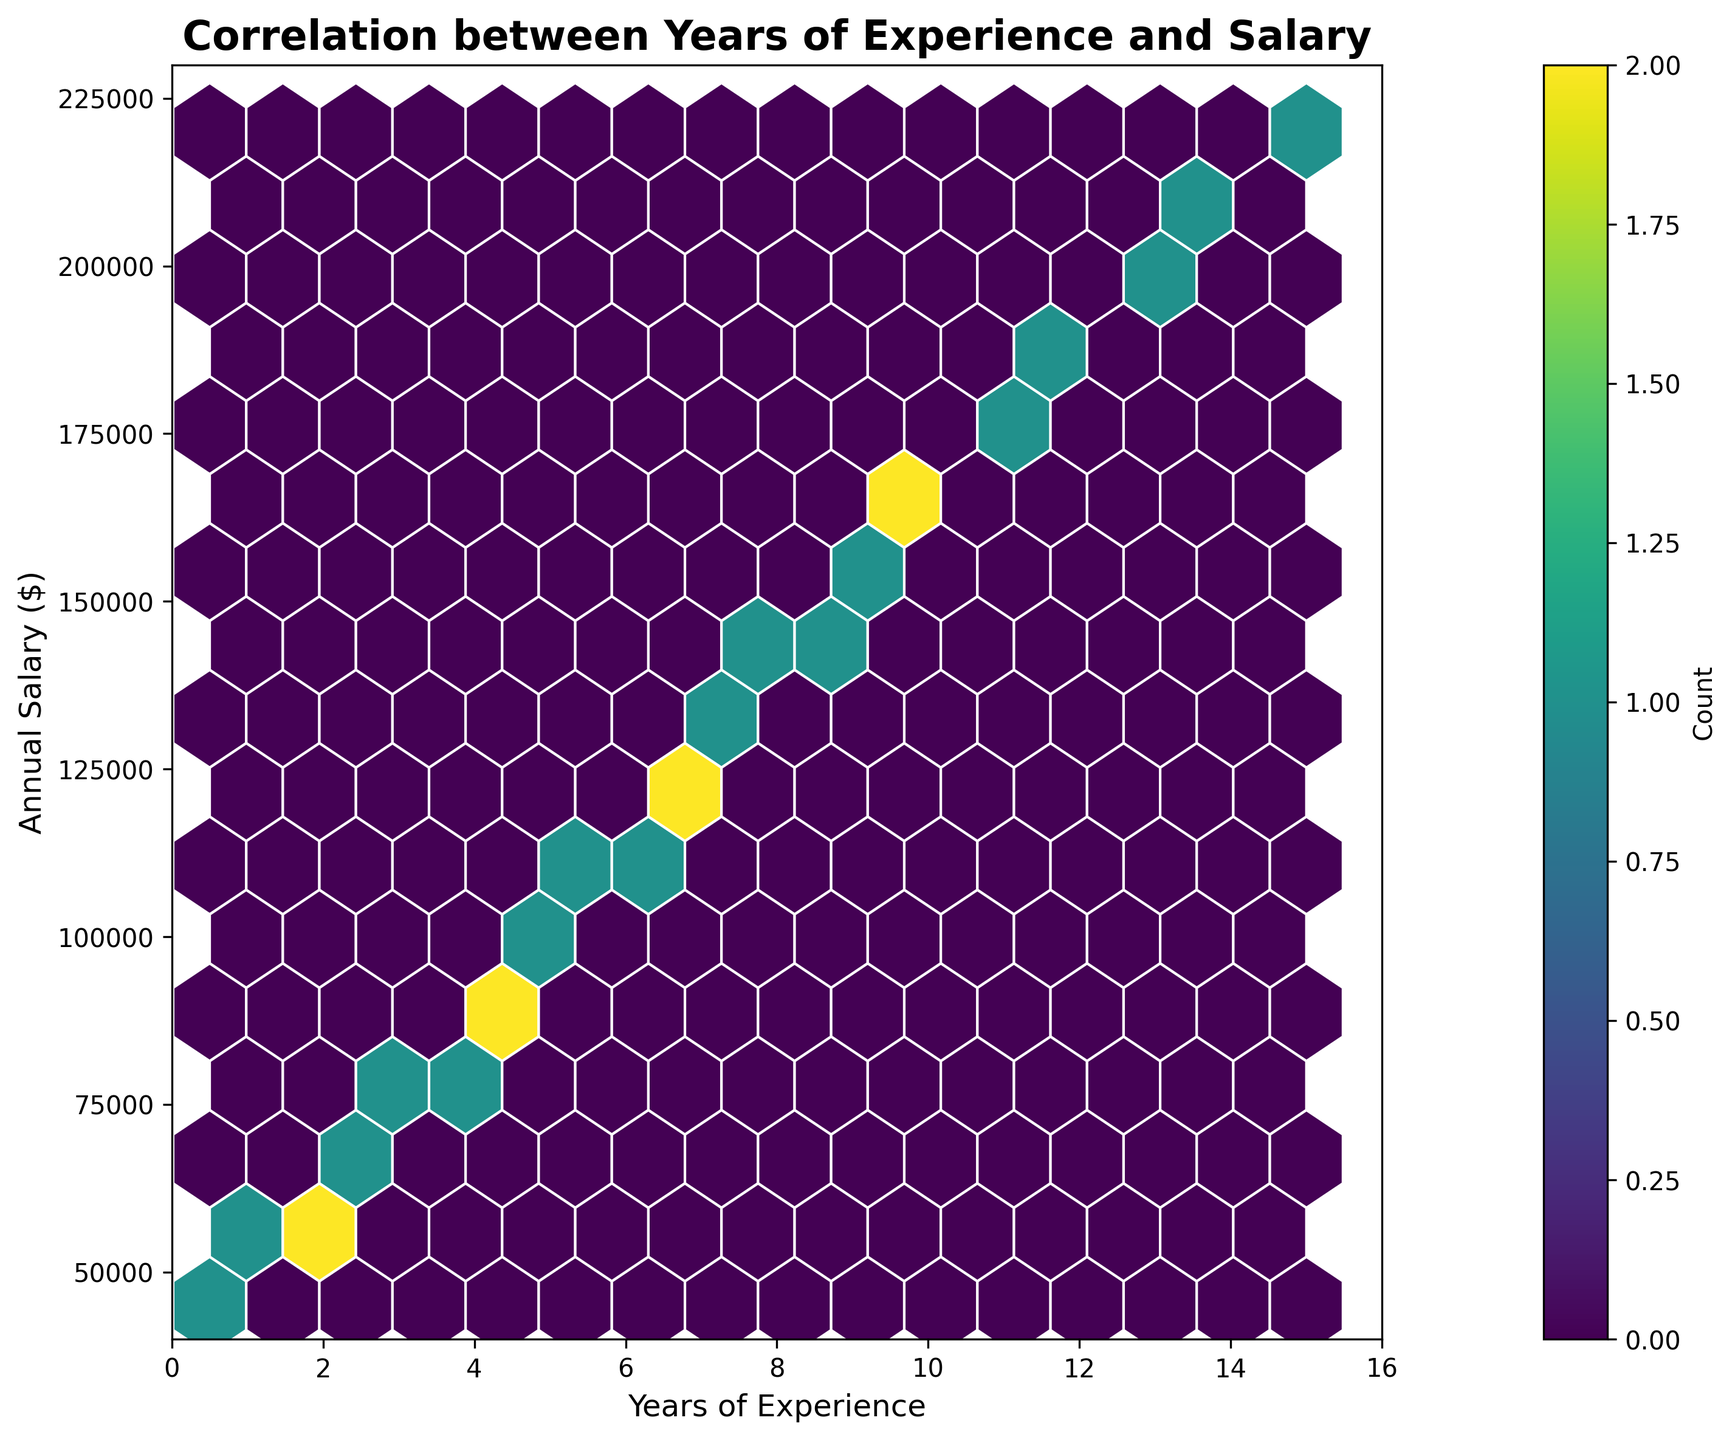What's the title of the chart? The title of the chart is located at the top and explains what the chart is about.
Answer: Correlation between Years of Experience and Salary What do the X and Y axes represent? The X-axis represents 'Years of Experience' and the Y-axis represents 'Annual Salary ($)', as labeled on the axes.
Answer: Years of Experience and Annual Salary ($) What are the minimum and maximum ranges for the X and Y axes? The minimum range for the X-axis is 0 and the maximum is 16; for the Y-axis, the minimum is 40,000 and the maximum is 230,000, as seen from the axis labels and ticks.
Answer: X-axis: 0 to 16, Y-axis: 40,000 to 230,000 Where is the highest density of data points located? The highest density of data points can be inferred from the area with the most intense color in the hexagonal bins. In this plot, the highest density appears around 4 to 6 years of experience and a salary range of 80,000 to 120,000.
Answer: Around 4 to 6 years of experience and 80,000 to 120,000 annual salary How does the density of data points change with increasing years of experience? The density of data points seems to decrease as the years of experience increases. The hexagonal bins become lighter in color as we move towards higher years of experience past the highest density area.
Answer: Decreases Is there a clear positive relationship between experience and salary? By observing the trend in the plot, as years of experience increase, the annual salary also increases. The high-density areas and overall distribution indicate a positive correlation.
Answer: Yes Based on the plot, what salary range do most data analysts with around 5 years of experience fall into? The area with the highest density bins around 5 years of experience suggests that most data analysts in this range have salaries between 98,000 and 112,000.
Answer: 98,000 to 112,000 How does the color in the hexbin plot represent the data? The color intensity in the hexbin plot represents the count of data points within each hexagon. Darker colors indicate a higher count of data points in that area.
Answer: Higher count with darker color What is the color of the hexagons with the least data points? The color of the hexagons with the least data points is lighter, almost fading towards the background color, indicating a lower count of data points.
Answer: Lighter color What is the importance of the color bar in the plot? The color bar provides a reference for interpreting the color intensity of hexagons, correlating different color levels to specific counts of data points within the hexagons.
Answer: Interpreting hexagon counts 